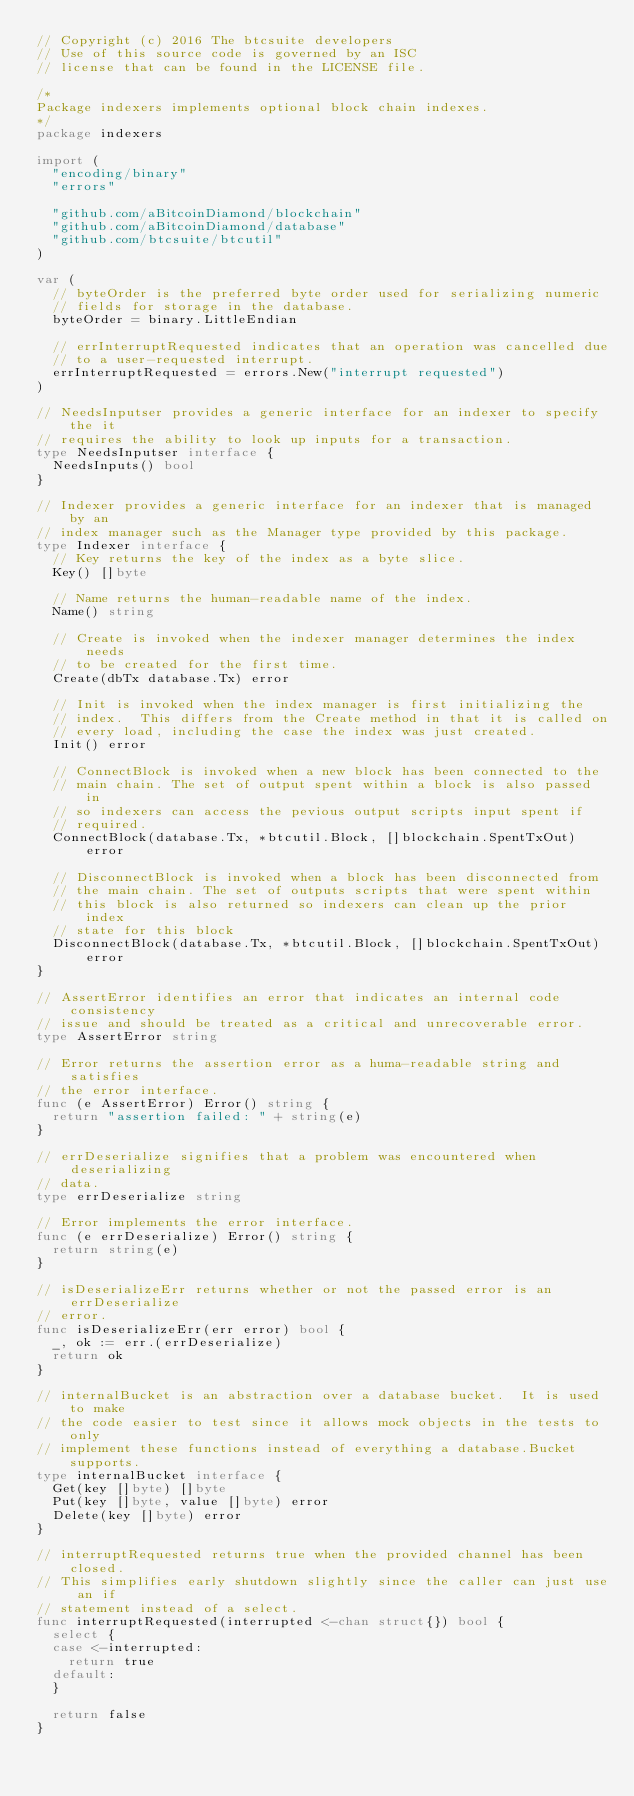Convert code to text. <code><loc_0><loc_0><loc_500><loc_500><_Go_>// Copyright (c) 2016 The btcsuite developers
// Use of this source code is governed by an ISC
// license that can be found in the LICENSE file.

/*
Package indexers implements optional block chain indexes.
*/
package indexers

import (
	"encoding/binary"
	"errors"

	"github.com/aBitcoinDiamond/blockchain"
	"github.com/aBitcoinDiamond/database"
	"github.com/btcsuite/btcutil"
)

var (
	// byteOrder is the preferred byte order used for serializing numeric
	// fields for storage in the database.
	byteOrder = binary.LittleEndian

	// errInterruptRequested indicates that an operation was cancelled due
	// to a user-requested interrupt.
	errInterruptRequested = errors.New("interrupt requested")
)

// NeedsInputser provides a generic interface for an indexer to specify the it
// requires the ability to look up inputs for a transaction.
type NeedsInputser interface {
	NeedsInputs() bool
}

// Indexer provides a generic interface for an indexer that is managed by an
// index manager such as the Manager type provided by this package.
type Indexer interface {
	// Key returns the key of the index as a byte slice.
	Key() []byte

	// Name returns the human-readable name of the index.
	Name() string

	// Create is invoked when the indexer manager determines the index needs
	// to be created for the first time.
	Create(dbTx database.Tx) error

	// Init is invoked when the index manager is first initializing the
	// index.  This differs from the Create method in that it is called on
	// every load, including the case the index was just created.
	Init() error

	// ConnectBlock is invoked when a new block has been connected to the
	// main chain. The set of output spent within a block is also passed in
	// so indexers can access the pevious output scripts input spent if
	// required.
	ConnectBlock(database.Tx, *btcutil.Block, []blockchain.SpentTxOut) error

	// DisconnectBlock is invoked when a block has been disconnected from
	// the main chain. The set of outputs scripts that were spent within
	// this block is also returned so indexers can clean up the prior index
	// state for this block
	DisconnectBlock(database.Tx, *btcutil.Block, []blockchain.SpentTxOut) error
}

// AssertError identifies an error that indicates an internal code consistency
// issue and should be treated as a critical and unrecoverable error.
type AssertError string

// Error returns the assertion error as a huma-readable string and satisfies
// the error interface.
func (e AssertError) Error() string {
	return "assertion failed: " + string(e)
}

// errDeserialize signifies that a problem was encountered when deserializing
// data.
type errDeserialize string

// Error implements the error interface.
func (e errDeserialize) Error() string {
	return string(e)
}

// isDeserializeErr returns whether or not the passed error is an errDeserialize
// error.
func isDeserializeErr(err error) bool {
	_, ok := err.(errDeserialize)
	return ok
}

// internalBucket is an abstraction over a database bucket.  It is used to make
// the code easier to test since it allows mock objects in the tests to only
// implement these functions instead of everything a database.Bucket supports.
type internalBucket interface {
	Get(key []byte) []byte
	Put(key []byte, value []byte) error
	Delete(key []byte) error
}

// interruptRequested returns true when the provided channel has been closed.
// This simplifies early shutdown slightly since the caller can just use an if
// statement instead of a select.
func interruptRequested(interrupted <-chan struct{}) bool {
	select {
	case <-interrupted:
		return true
	default:
	}

	return false
}
</code> 